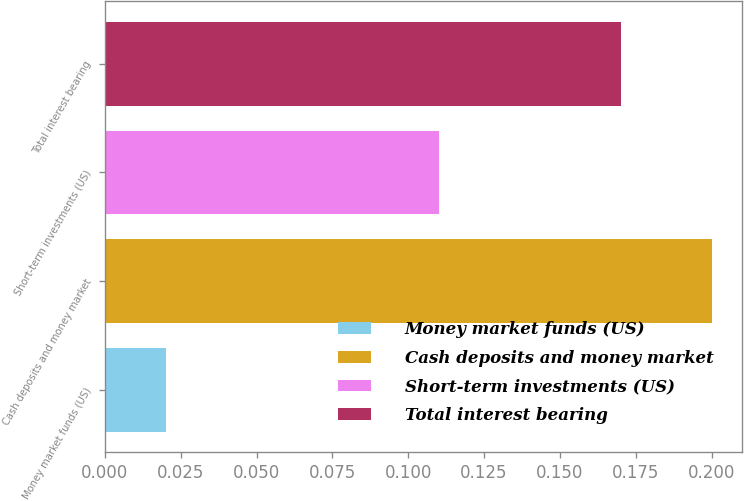<chart> <loc_0><loc_0><loc_500><loc_500><bar_chart><fcel>Money market funds (US)<fcel>Cash deposits and money market<fcel>Short-term investments (US)<fcel>Total interest bearing<nl><fcel>0.02<fcel>0.2<fcel>0.11<fcel>0.17<nl></chart> 